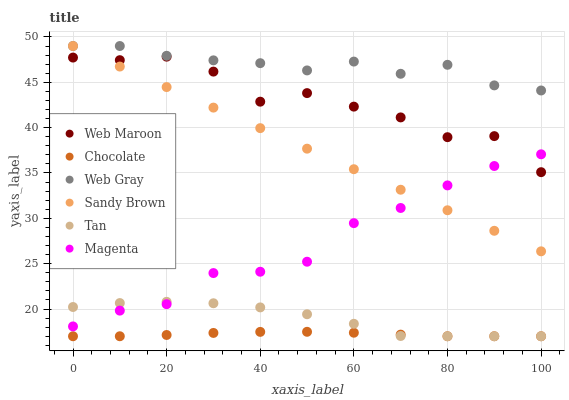Does Chocolate have the minimum area under the curve?
Answer yes or no. Yes. Does Web Gray have the maximum area under the curve?
Answer yes or no. Yes. Does Web Maroon have the minimum area under the curve?
Answer yes or no. No. Does Web Maroon have the maximum area under the curve?
Answer yes or no. No. Is Sandy Brown the smoothest?
Answer yes or no. Yes. Is Web Maroon the roughest?
Answer yes or no. Yes. Is Chocolate the smoothest?
Answer yes or no. No. Is Chocolate the roughest?
Answer yes or no. No. Does Chocolate have the lowest value?
Answer yes or no. Yes. Does Web Maroon have the lowest value?
Answer yes or no. No. Does Sandy Brown have the highest value?
Answer yes or no. Yes. Does Web Maroon have the highest value?
Answer yes or no. No. Is Web Maroon less than Web Gray?
Answer yes or no. Yes. Is Web Maroon greater than Tan?
Answer yes or no. Yes. Does Chocolate intersect Tan?
Answer yes or no. Yes. Is Chocolate less than Tan?
Answer yes or no. No. Is Chocolate greater than Tan?
Answer yes or no. No. Does Web Maroon intersect Web Gray?
Answer yes or no. No. 